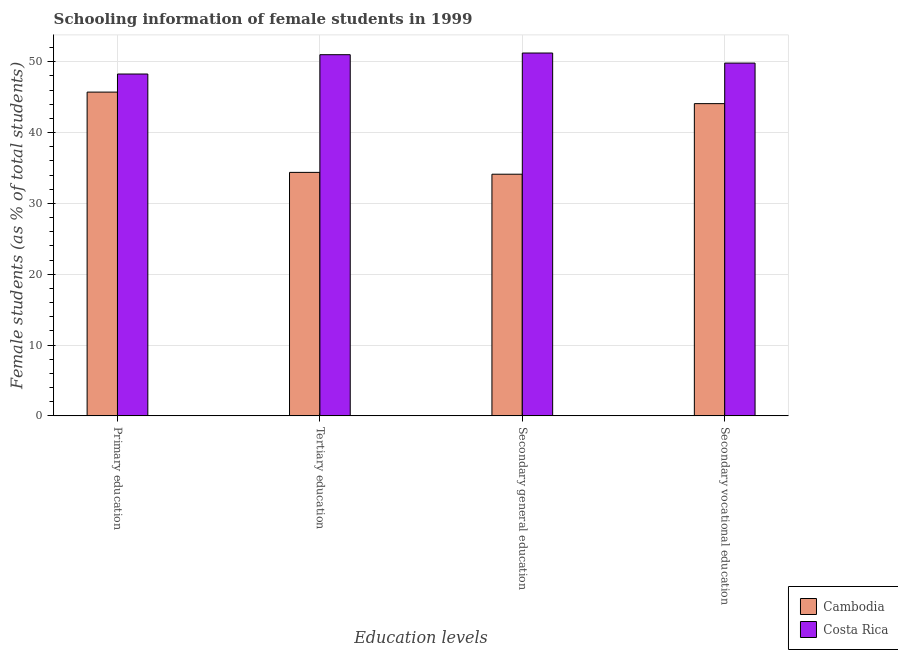Are the number of bars per tick equal to the number of legend labels?
Provide a succinct answer. Yes. How many bars are there on the 1st tick from the right?
Your response must be concise. 2. What is the label of the 3rd group of bars from the left?
Provide a succinct answer. Secondary general education. What is the percentage of female students in secondary vocational education in Cambodia?
Ensure brevity in your answer.  44.09. Across all countries, what is the maximum percentage of female students in secondary education?
Ensure brevity in your answer.  51.24. Across all countries, what is the minimum percentage of female students in secondary education?
Keep it short and to the point. 34.13. In which country was the percentage of female students in secondary education maximum?
Your answer should be very brief. Costa Rica. In which country was the percentage of female students in secondary education minimum?
Your answer should be compact. Cambodia. What is the total percentage of female students in secondary education in the graph?
Keep it short and to the point. 85.37. What is the difference between the percentage of female students in tertiary education in Cambodia and that in Costa Rica?
Make the answer very short. -16.62. What is the difference between the percentage of female students in tertiary education in Costa Rica and the percentage of female students in secondary vocational education in Cambodia?
Your answer should be very brief. 6.91. What is the average percentage of female students in primary education per country?
Your answer should be very brief. 47. What is the difference between the percentage of female students in primary education and percentage of female students in secondary vocational education in Cambodia?
Make the answer very short. 1.63. What is the ratio of the percentage of female students in secondary education in Costa Rica to that in Cambodia?
Provide a succinct answer. 1.5. Is the percentage of female students in primary education in Cambodia less than that in Costa Rica?
Provide a short and direct response. Yes. What is the difference between the highest and the second highest percentage of female students in primary education?
Keep it short and to the point. 2.55. What is the difference between the highest and the lowest percentage of female students in secondary vocational education?
Ensure brevity in your answer.  5.73. In how many countries, is the percentage of female students in secondary vocational education greater than the average percentage of female students in secondary vocational education taken over all countries?
Your answer should be very brief. 1. Is the sum of the percentage of female students in secondary education in Costa Rica and Cambodia greater than the maximum percentage of female students in secondary vocational education across all countries?
Give a very brief answer. Yes. Is it the case that in every country, the sum of the percentage of female students in secondary vocational education and percentage of female students in secondary education is greater than the sum of percentage of female students in tertiary education and percentage of female students in primary education?
Provide a short and direct response. No. What does the 1st bar from the right in Primary education represents?
Your response must be concise. Costa Rica. Are all the bars in the graph horizontal?
Make the answer very short. No. How many countries are there in the graph?
Provide a succinct answer. 2. Does the graph contain any zero values?
Offer a very short reply. No. Does the graph contain grids?
Ensure brevity in your answer.  Yes. How many legend labels are there?
Provide a succinct answer. 2. How are the legend labels stacked?
Your response must be concise. Vertical. What is the title of the graph?
Keep it short and to the point. Schooling information of female students in 1999. What is the label or title of the X-axis?
Your answer should be very brief. Education levels. What is the label or title of the Y-axis?
Offer a terse response. Female students (as % of total students). What is the Female students (as % of total students) in Cambodia in Primary education?
Give a very brief answer. 45.72. What is the Female students (as % of total students) in Costa Rica in Primary education?
Give a very brief answer. 48.27. What is the Female students (as % of total students) in Cambodia in Tertiary education?
Your answer should be very brief. 34.38. What is the Female students (as % of total students) of Costa Rica in Tertiary education?
Offer a terse response. 51. What is the Female students (as % of total students) of Cambodia in Secondary general education?
Give a very brief answer. 34.13. What is the Female students (as % of total students) in Costa Rica in Secondary general education?
Offer a terse response. 51.24. What is the Female students (as % of total students) in Cambodia in Secondary vocational education?
Keep it short and to the point. 44.09. What is the Female students (as % of total students) of Costa Rica in Secondary vocational education?
Make the answer very short. 49.82. Across all Education levels, what is the maximum Female students (as % of total students) in Cambodia?
Provide a succinct answer. 45.72. Across all Education levels, what is the maximum Female students (as % of total students) of Costa Rica?
Provide a succinct answer. 51.24. Across all Education levels, what is the minimum Female students (as % of total students) in Cambodia?
Your answer should be compact. 34.13. Across all Education levels, what is the minimum Female students (as % of total students) of Costa Rica?
Your answer should be compact. 48.27. What is the total Female students (as % of total students) of Cambodia in the graph?
Offer a very short reply. 158.33. What is the total Female students (as % of total students) of Costa Rica in the graph?
Keep it short and to the point. 200.34. What is the difference between the Female students (as % of total students) of Cambodia in Primary education and that in Tertiary education?
Offer a very short reply. 11.34. What is the difference between the Female students (as % of total students) of Costa Rica in Primary education and that in Tertiary education?
Keep it short and to the point. -2.73. What is the difference between the Female students (as % of total students) in Cambodia in Primary education and that in Secondary general education?
Your answer should be very brief. 11.59. What is the difference between the Female students (as % of total students) of Costa Rica in Primary education and that in Secondary general education?
Your answer should be very brief. -2.97. What is the difference between the Female students (as % of total students) of Cambodia in Primary education and that in Secondary vocational education?
Provide a succinct answer. 1.63. What is the difference between the Female students (as % of total students) of Costa Rica in Primary education and that in Secondary vocational education?
Your answer should be very brief. -1.54. What is the difference between the Female students (as % of total students) of Cambodia in Tertiary education and that in Secondary general education?
Offer a very short reply. 0.26. What is the difference between the Female students (as % of total students) of Costa Rica in Tertiary education and that in Secondary general education?
Offer a terse response. -0.24. What is the difference between the Female students (as % of total students) of Cambodia in Tertiary education and that in Secondary vocational education?
Your answer should be very brief. -9.71. What is the difference between the Female students (as % of total students) in Costa Rica in Tertiary education and that in Secondary vocational education?
Offer a very short reply. 1.19. What is the difference between the Female students (as % of total students) of Cambodia in Secondary general education and that in Secondary vocational education?
Provide a short and direct response. -9.97. What is the difference between the Female students (as % of total students) in Costa Rica in Secondary general education and that in Secondary vocational education?
Ensure brevity in your answer.  1.42. What is the difference between the Female students (as % of total students) of Cambodia in Primary education and the Female students (as % of total students) of Costa Rica in Tertiary education?
Offer a terse response. -5.28. What is the difference between the Female students (as % of total students) in Cambodia in Primary education and the Female students (as % of total students) in Costa Rica in Secondary general education?
Offer a very short reply. -5.52. What is the difference between the Female students (as % of total students) in Cambodia in Primary education and the Female students (as % of total students) in Costa Rica in Secondary vocational education?
Ensure brevity in your answer.  -4.1. What is the difference between the Female students (as % of total students) in Cambodia in Tertiary education and the Female students (as % of total students) in Costa Rica in Secondary general education?
Provide a succinct answer. -16.86. What is the difference between the Female students (as % of total students) of Cambodia in Tertiary education and the Female students (as % of total students) of Costa Rica in Secondary vocational education?
Offer a very short reply. -15.43. What is the difference between the Female students (as % of total students) of Cambodia in Secondary general education and the Female students (as % of total students) of Costa Rica in Secondary vocational education?
Your response must be concise. -15.69. What is the average Female students (as % of total students) of Cambodia per Education levels?
Give a very brief answer. 39.58. What is the average Female students (as % of total students) in Costa Rica per Education levels?
Offer a terse response. 50.08. What is the difference between the Female students (as % of total students) of Cambodia and Female students (as % of total students) of Costa Rica in Primary education?
Your answer should be very brief. -2.55. What is the difference between the Female students (as % of total students) of Cambodia and Female students (as % of total students) of Costa Rica in Tertiary education?
Ensure brevity in your answer.  -16.62. What is the difference between the Female students (as % of total students) of Cambodia and Female students (as % of total students) of Costa Rica in Secondary general education?
Keep it short and to the point. -17.11. What is the difference between the Female students (as % of total students) of Cambodia and Female students (as % of total students) of Costa Rica in Secondary vocational education?
Keep it short and to the point. -5.73. What is the ratio of the Female students (as % of total students) in Cambodia in Primary education to that in Tertiary education?
Make the answer very short. 1.33. What is the ratio of the Female students (as % of total students) in Costa Rica in Primary education to that in Tertiary education?
Offer a very short reply. 0.95. What is the ratio of the Female students (as % of total students) of Cambodia in Primary education to that in Secondary general education?
Your answer should be very brief. 1.34. What is the ratio of the Female students (as % of total students) in Costa Rica in Primary education to that in Secondary general education?
Provide a short and direct response. 0.94. What is the ratio of the Female students (as % of total students) of Cambodia in Primary education to that in Secondary vocational education?
Provide a short and direct response. 1.04. What is the ratio of the Female students (as % of total students) of Cambodia in Tertiary education to that in Secondary general education?
Your answer should be compact. 1.01. What is the ratio of the Female students (as % of total students) of Cambodia in Tertiary education to that in Secondary vocational education?
Provide a succinct answer. 0.78. What is the ratio of the Female students (as % of total students) in Costa Rica in Tertiary education to that in Secondary vocational education?
Your response must be concise. 1.02. What is the ratio of the Female students (as % of total students) in Cambodia in Secondary general education to that in Secondary vocational education?
Your answer should be compact. 0.77. What is the ratio of the Female students (as % of total students) of Costa Rica in Secondary general education to that in Secondary vocational education?
Ensure brevity in your answer.  1.03. What is the difference between the highest and the second highest Female students (as % of total students) in Cambodia?
Make the answer very short. 1.63. What is the difference between the highest and the second highest Female students (as % of total students) of Costa Rica?
Your answer should be compact. 0.24. What is the difference between the highest and the lowest Female students (as % of total students) of Cambodia?
Offer a terse response. 11.59. What is the difference between the highest and the lowest Female students (as % of total students) in Costa Rica?
Give a very brief answer. 2.97. 